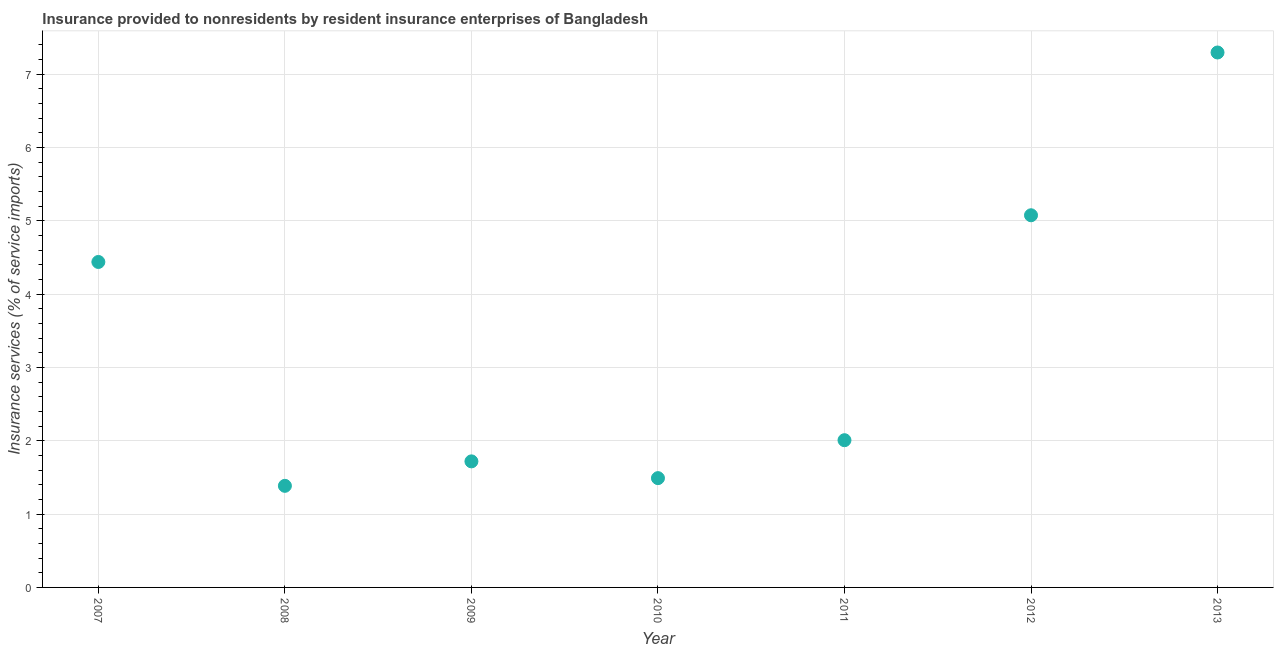What is the insurance and financial services in 2007?
Provide a short and direct response. 4.44. Across all years, what is the maximum insurance and financial services?
Keep it short and to the point. 7.3. Across all years, what is the minimum insurance and financial services?
Give a very brief answer. 1.39. In which year was the insurance and financial services maximum?
Provide a succinct answer. 2013. In which year was the insurance and financial services minimum?
Offer a very short reply. 2008. What is the sum of the insurance and financial services?
Offer a terse response. 23.41. What is the difference between the insurance and financial services in 2010 and 2011?
Provide a succinct answer. -0.52. What is the average insurance and financial services per year?
Keep it short and to the point. 3.34. What is the median insurance and financial services?
Offer a terse response. 2.01. In how many years, is the insurance and financial services greater than 4.8 %?
Your answer should be very brief. 2. Do a majority of the years between 2010 and 2007 (inclusive) have insurance and financial services greater than 7.2 %?
Ensure brevity in your answer.  Yes. What is the ratio of the insurance and financial services in 2007 to that in 2010?
Give a very brief answer. 2.98. Is the difference between the insurance and financial services in 2010 and 2013 greater than the difference between any two years?
Give a very brief answer. No. What is the difference between the highest and the second highest insurance and financial services?
Offer a terse response. 2.22. What is the difference between the highest and the lowest insurance and financial services?
Offer a very short reply. 5.91. In how many years, is the insurance and financial services greater than the average insurance and financial services taken over all years?
Provide a short and direct response. 3. How many dotlines are there?
Offer a terse response. 1. How many years are there in the graph?
Offer a terse response. 7. What is the difference between two consecutive major ticks on the Y-axis?
Your response must be concise. 1. Are the values on the major ticks of Y-axis written in scientific E-notation?
Keep it short and to the point. No. Does the graph contain grids?
Give a very brief answer. Yes. What is the title of the graph?
Provide a succinct answer. Insurance provided to nonresidents by resident insurance enterprises of Bangladesh. What is the label or title of the Y-axis?
Offer a terse response. Insurance services (% of service imports). What is the Insurance services (% of service imports) in 2007?
Offer a very short reply. 4.44. What is the Insurance services (% of service imports) in 2008?
Your answer should be very brief. 1.39. What is the Insurance services (% of service imports) in 2009?
Ensure brevity in your answer.  1.72. What is the Insurance services (% of service imports) in 2010?
Offer a terse response. 1.49. What is the Insurance services (% of service imports) in 2011?
Make the answer very short. 2.01. What is the Insurance services (% of service imports) in 2012?
Your answer should be compact. 5.08. What is the Insurance services (% of service imports) in 2013?
Provide a succinct answer. 7.3. What is the difference between the Insurance services (% of service imports) in 2007 and 2008?
Your answer should be compact. 3.05. What is the difference between the Insurance services (% of service imports) in 2007 and 2009?
Offer a terse response. 2.72. What is the difference between the Insurance services (% of service imports) in 2007 and 2010?
Give a very brief answer. 2.95. What is the difference between the Insurance services (% of service imports) in 2007 and 2011?
Keep it short and to the point. 2.43. What is the difference between the Insurance services (% of service imports) in 2007 and 2012?
Your answer should be very brief. -0.64. What is the difference between the Insurance services (% of service imports) in 2007 and 2013?
Offer a very short reply. -2.86. What is the difference between the Insurance services (% of service imports) in 2008 and 2009?
Make the answer very short. -0.33. What is the difference between the Insurance services (% of service imports) in 2008 and 2010?
Ensure brevity in your answer.  -0.11. What is the difference between the Insurance services (% of service imports) in 2008 and 2011?
Your answer should be compact. -0.62. What is the difference between the Insurance services (% of service imports) in 2008 and 2012?
Give a very brief answer. -3.69. What is the difference between the Insurance services (% of service imports) in 2008 and 2013?
Your answer should be compact. -5.91. What is the difference between the Insurance services (% of service imports) in 2009 and 2010?
Keep it short and to the point. 0.23. What is the difference between the Insurance services (% of service imports) in 2009 and 2011?
Ensure brevity in your answer.  -0.29. What is the difference between the Insurance services (% of service imports) in 2009 and 2012?
Your answer should be very brief. -3.36. What is the difference between the Insurance services (% of service imports) in 2009 and 2013?
Your response must be concise. -5.58. What is the difference between the Insurance services (% of service imports) in 2010 and 2011?
Offer a very short reply. -0.52. What is the difference between the Insurance services (% of service imports) in 2010 and 2012?
Keep it short and to the point. -3.59. What is the difference between the Insurance services (% of service imports) in 2010 and 2013?
Your answer should be very brief. -5.81. What is the difference between the Insurance services (% of service imports) in 2011 and 2012?
Your response must be concise. -3.07. What is the difference between the Insurance services (% of service imports) in 2011 and 2013?
Offer a terse response. -5.29. What is the difference between the Insurance services (% of service imports) in 2012 and 2013?
Offer a very short reply. -2.22. What is the ratio of the Insurance services (% of service imports) in 2007 to that in 2008?
Your answer should be very brief. 3.2. What is the ratio of the Insurance services (% of service imports) in 2007 to that in 2009?
Provide a succinct answer. 2.58. What is the ratio of the Insurance services (% of service imports) in 2007 to that in 2010?
Make the answer very short. 2.98. What is the ratio of the Insurance services (% of service imports) in 2007 to that in 2011?
Offer a terse response. 2.21. What is the ratio of the Insurance services (% of service imports) in 2007 to that in 2012?
Make the answer very short. 0.88. What is the ratio of the Insurance services (% of service imports) in 2007 to that in 2013?
Ensure brevity in your answer.  0.61. What is the ratio of the Insurance services (% of service imports) in 2008 to that in 2009?
Offer a terse response. 0.81. What is the ratio of the Insurance services (% of service imports) in 2008 to that in 2011?
Provide a succinct answer. 0.69. What is the ratio of the Insurance services (% of service imports) in 2008 to that in 2012?
Provide a succinct answer. 0.27. What is the ratio of the Insurance services (% of service imports) in 2008 to that in 2013?
Provide a succinct answer. 0.19. What is the ratio of the Insurance services (% of service imports) in 2009 to that in 2010?
Ensure brevity in your answer.  1.15. What is the ratio of the Insurance services (% of service imports) in 2009 to that in 2011?
Your response must be concise. 0.86. What is the ratio of the Insurance services (% of service imports) in 2009 to that in 2012?
Provide a succinct answer. 0.34. What is the ratio of the Insurance services (% of service imports) in 2009 to that in 2013?
Provide a short and direct response. 0.24. What is the ratio of the Insurance services (% of service imports) in 2010 to that in 2011?
Ensure brevity in your answer.  0.74. What is the ratio of the Insurance services (% of service imports) in 2010 to that in 2012?
Make the answer very short. 0.29. What is the ratio of the Insurance services (% of service imports) in 2010 to that in 2013?
Provide a short and direct response. 0.2. What is the ratio of the Insurance services (% of service imports) in 2011 to that in 2012?
Offer a very short reply. 0.4. What is the ratio of the Insurance services (% of service imports) in 2011 to that in 2013?
Your answer should be very brief. 0.28. What is the ratio of the Insurance services (% of service imports) in 2012 to that in 2013?
Your answer should be very brief. 0.7. 